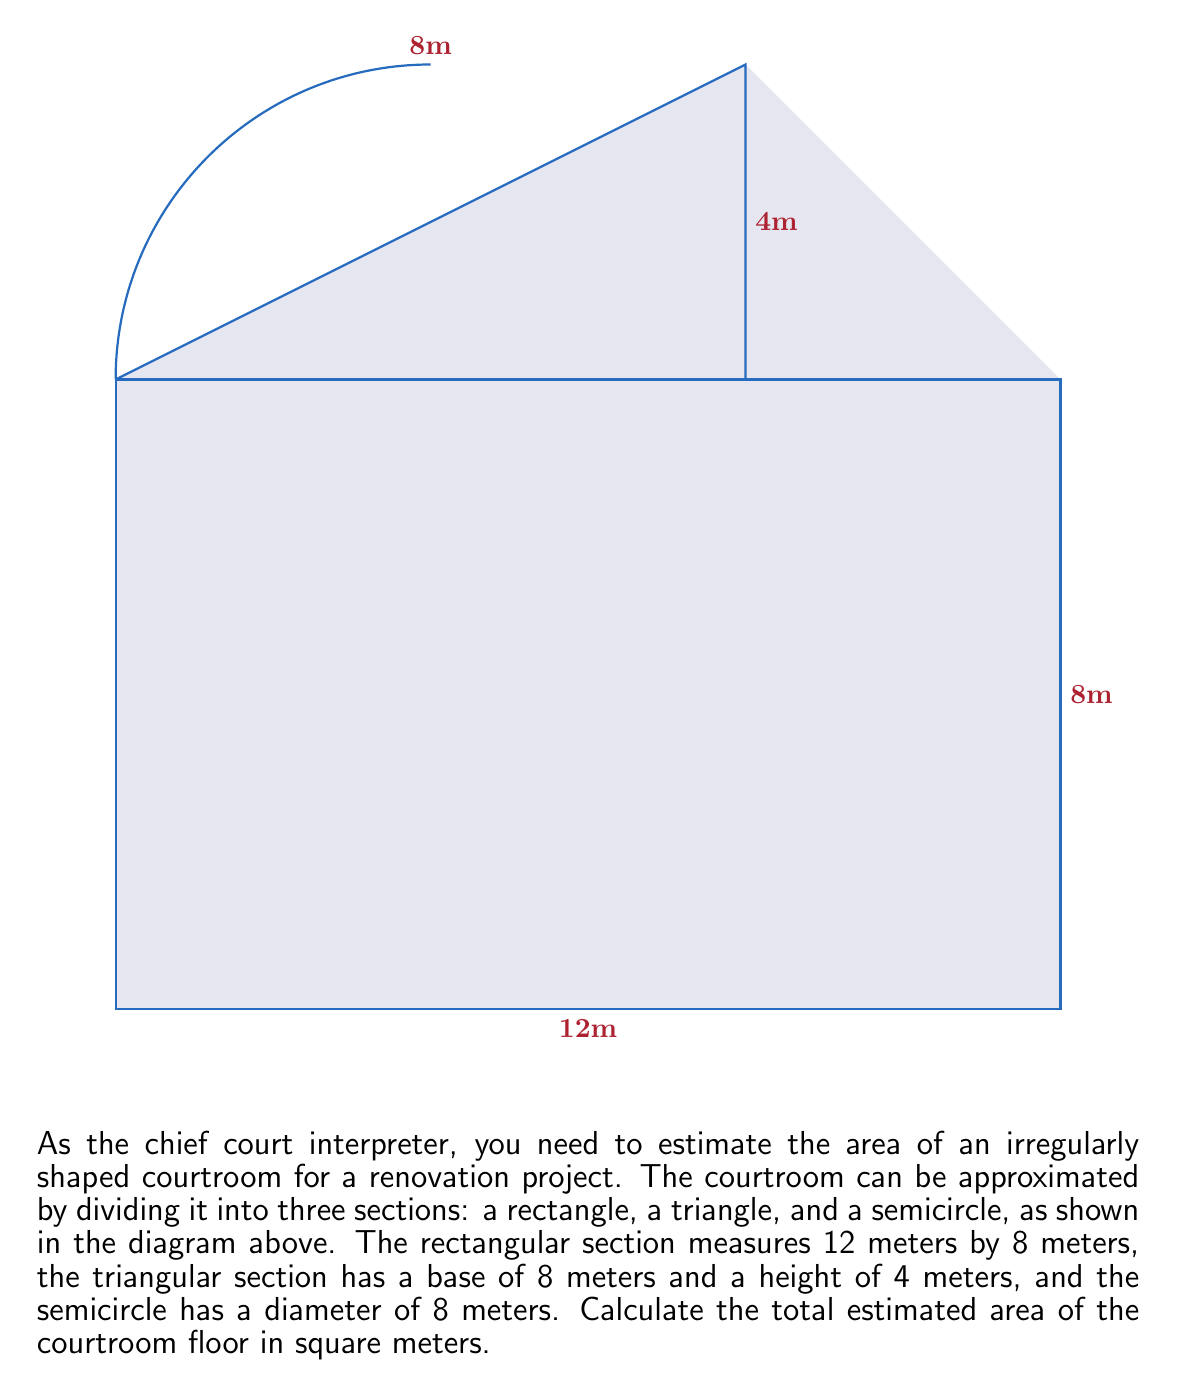Can you answer this question? To estimate the total area of the irregularly shaped courtroom, we need to calculate the areas of the three sections separately and then sum them up:

1. Rectangle area:
   $A_r = l \times w = 12 \text{ m} \times 8 \text{ m} = 96 \text{ m}^2$

2. Triangle area:
   $A_t = \frac{1}{2} \times b \times h = \frac{1}{2} \times 8 \text{ m} \times 4 \text{ m} = 16 \text{ m}^2$

3. Semicircle area:
   First, calculate the radius: $r = \frac{diameter}{2} = \frac{8 \text{ m}}{2} = 4 \text{ m}$
   $A_s = \frac{1}{2} \times \pi r^2 = \frac{1}{2} \times \pi \times (4 \text{ m})^2 = 8\pi \text{ m}^2$

Now, sum up all the areas:

$$A_{total} = A_r + A_t + A_s = 96 \text{ m}^2 + 16 \text{ m}^2 + 8\pi \text{ m}^2$$

$$A_{total} = 112 + 8\pi \text{ m}^2$$

$$A_{total} \approx 137.14 \text{ m}^2$$

Therefore, the estimated area of the courtroom floor is approximately 137.14 square meters.
Answer: $137.14 \text{ m}^2$ 